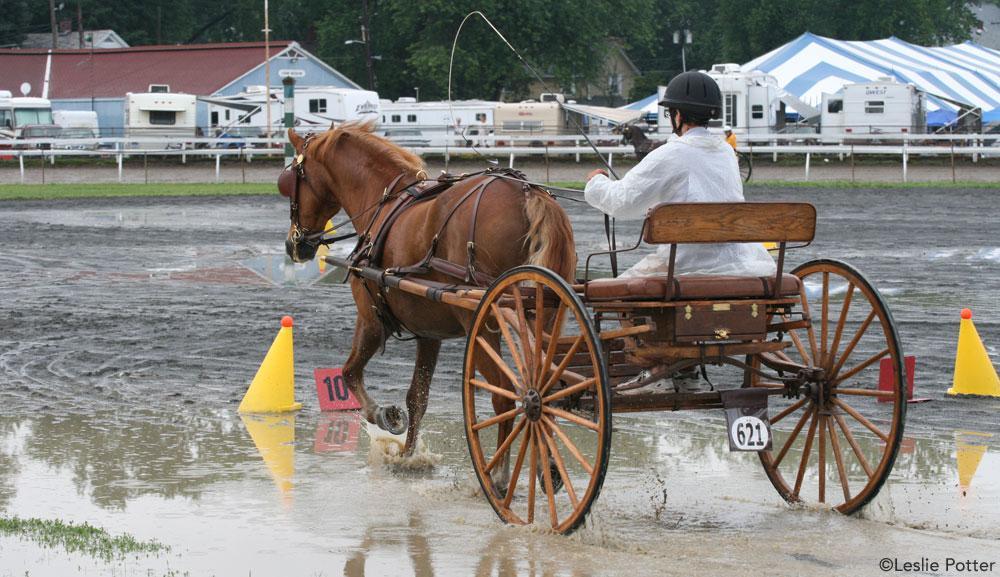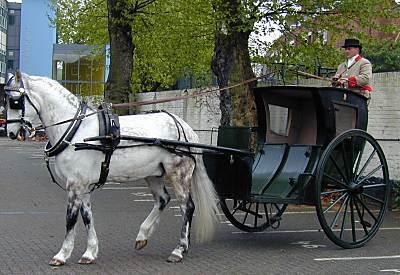The first image is the image on the left, the second image is the image on the right. Evaluate the accuracy of this statement regarding the images: "There is a person in the image on the right.". Is it true? Answer yes or no. Yes. The first image is the image on the left, the second image is the image on the right. Evaluate the accuracy of this statement regarding the images: "At least one image shows a cart that is not hooked up to a horse.". Is it true? Answer yes or no. No. 